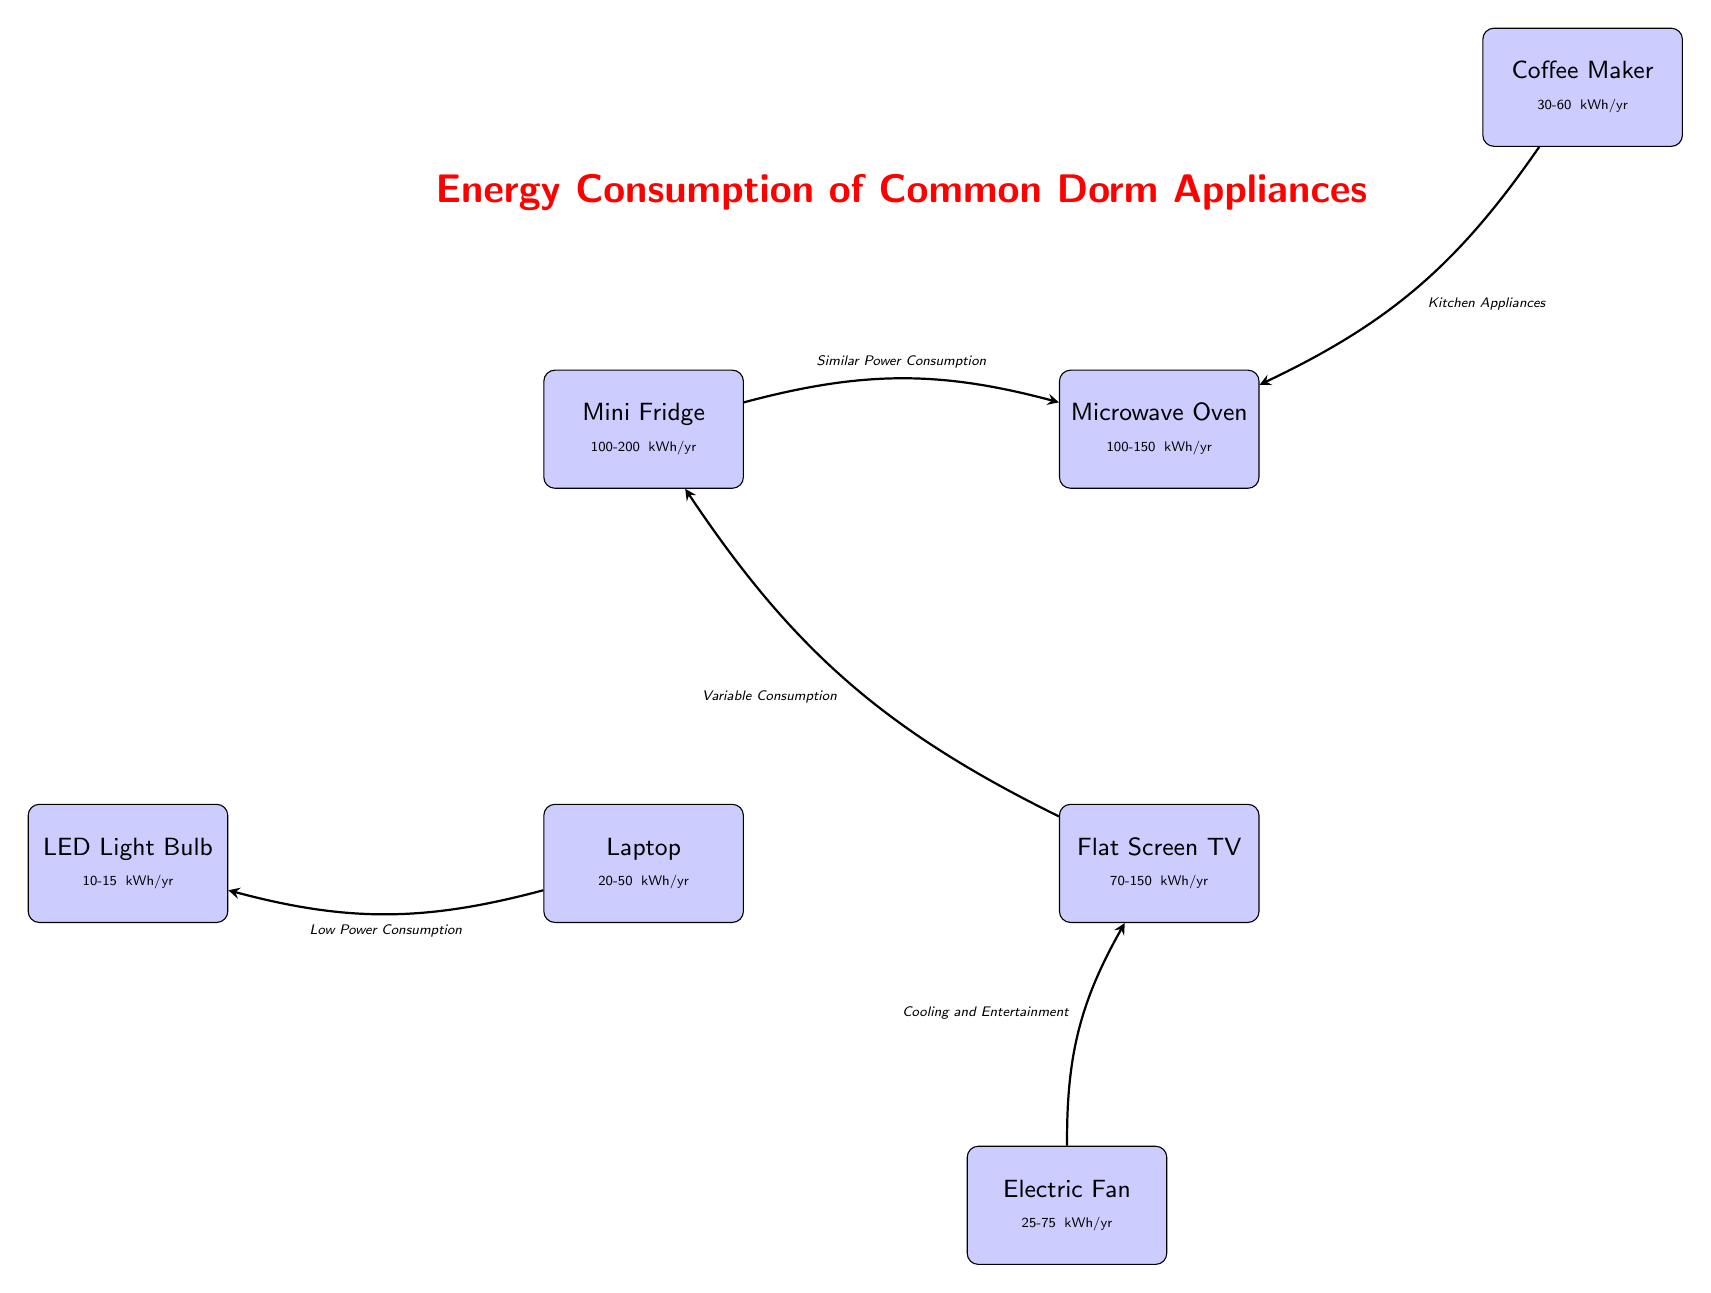What's the energy consumption range of a mini fridge? The diagram indicates that a mini fridge consumes between 100 to 200 kWh per year. This information is directly stated beneath the mini fridge node in the diagram.
Answer: 100-200 kWh/yr Which appliance has the lowest power consumption? In the diagram, the LED light bulb has a power consumption range of 10 to 15 kWh per year, which is lower than all other appliances listed.
Answer: LED Light Bulb What is the relationship between the mini fridge and the microwave oven? The diagram shows an arrow connecting the mini fridge and microwave oven with the label "Similar Power Consumption." This indicates that their energy usages are comparable.
Answer: Similar Power Consumption How many appliances are represented in the diagram? The diagram lists a total of six appliances: mini fridge, microwave oven, laptop, flat screen TV, electric fan, and coffee maker. By counting each distinct appliance node, we find there are six in total.
Answer: 6 Which two appliances are categorized under "Kitchen Appliances"? The diagram connects the coffee maker and microwave oven with the label "Kitchen Appliances." This signifies that both of these appliances are related to kitchen use.
Answer: Coffee Maker, Microwave Oven What is the power consumption range of a flat screen TV? The diagram indicates that the flat screen TV has a variable consumption range of 70 to 150 kWh per year. This value is displayed directly below the TV node.
Answer: 70-150 kWh/yr Which appliances have a power consumption range that overlaps with the microwave? The diagram shows that the mini fridge (100-200 kWh/yr) and the flat screen TV (70-150 kWh/yr) have overlapping power consumption ranges with the microwave oven, which is 100-150 kWh/yr. Therefore, both appliances have similar or overlapping energy usage values.
Answer: Mini Fridge, Flat Screen TV How does the power consumption of the laptop compare to the electric fan? The laptop's power consumption ranges from 20 to 50 kWh/yr, while the electric fan's ranges from 25 to 75 kWh/yr. Since there is an overlap in their ranges, both devices consume a comparable amount of energy, with the fan potentially consuming more at the upper end.
Answer: Comparable Which appliance is associated with "Cooling and Entertainment"? The diagram connects the electric fan and flat screen TV with the label "Cooling and Entertainment," indicating that both are involved in providing comfort and leisure.
Answer: Electric Fan, Flat Screen TV 